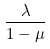<formula> <loc_0><loc_0><loc_500><loc_500>\frac { \lambda } { 1 - \mu }</formula> 